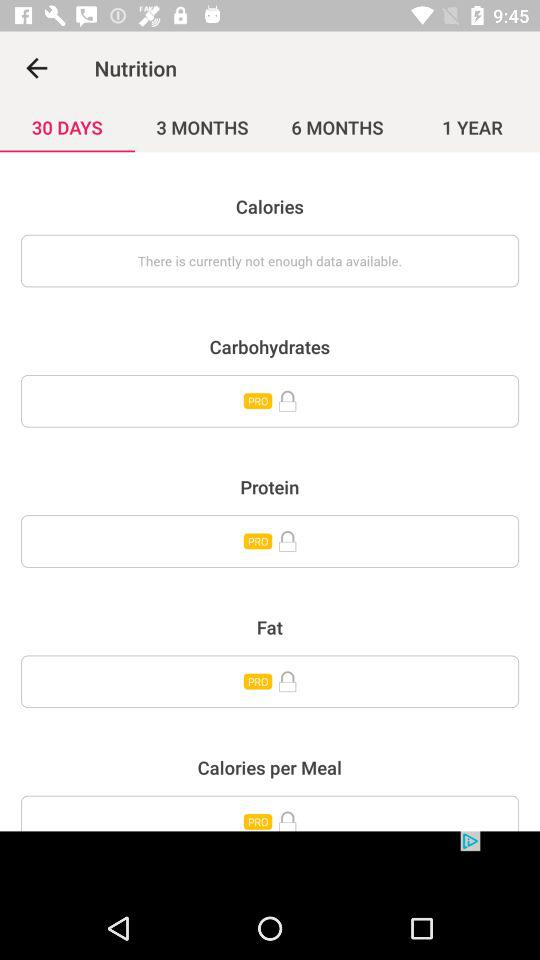Which category does not have enough data? The category "Calories" does not have enough data. 